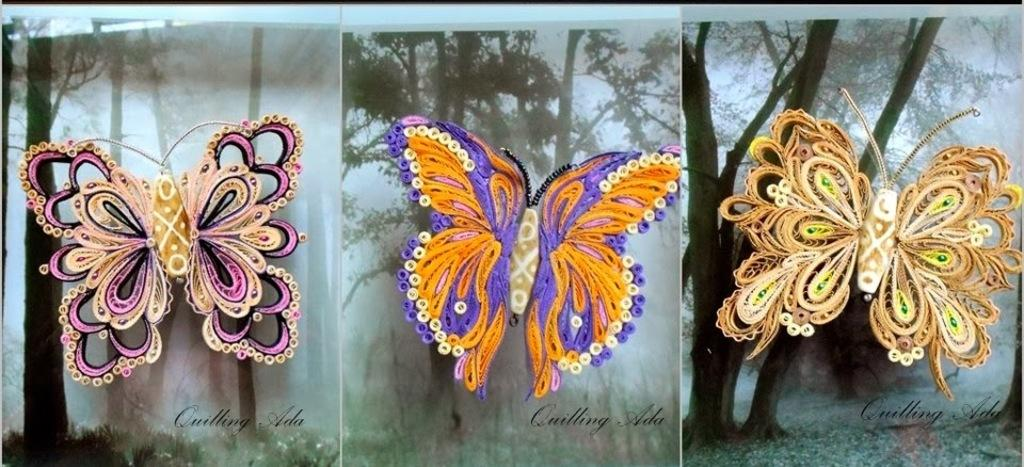How many images are included in the collage? The collage is made up of three images. What is the common subject in each image of the collage? Each image contains butterflies. How do the butterflies in the collage differ from one another? The butterflies have different sizes and colors. What can be seen in the background of the collage? There are trees in the background of the collage. What type of nail is being used to hold the food in the crate in the image? There is no nail, food, or crate present in the image; it is a collage of butterflies with trees in the background. 